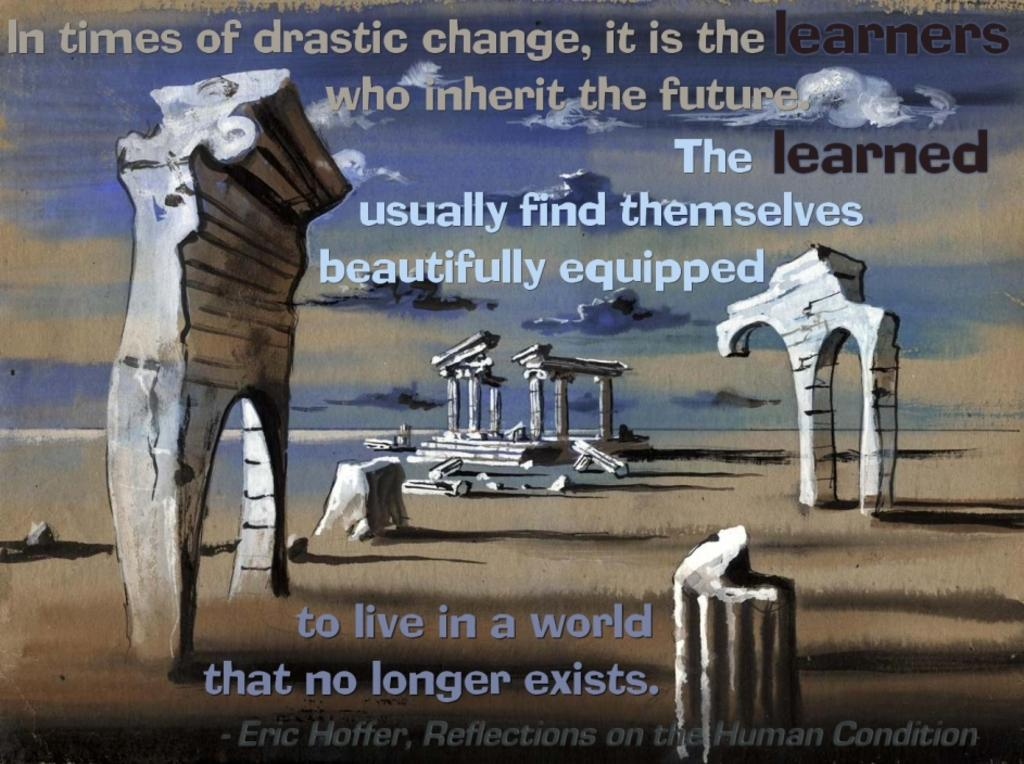What is present in the image that contains visual and textual information? There is a poster in the image that contains images and text. Can you describe the images on the poster? Unfortunately, the specific images on the poster cannot be described without more information. What type of information is conveyed through the text on the poster? The content of the text on the poster cannot be determined without more information. How much coal is being used by the brother in the image? There is no mention of coal or a brother in the image, so this question cannot be answered. 